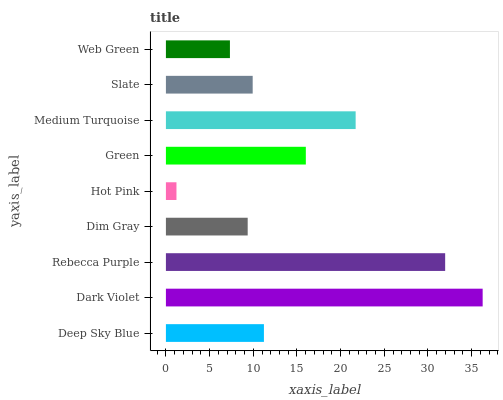Is Hot Pink the minimum?
Answer yes or no. Yes. Is Dark Violet the maximum?
Answer yes or no. Yes. Is Rebecca Purple the minimum?
Answer yes or no. No. Is Rebecca Purple the maximum?
Answer yes or no. No. Is Dark Violet greater than Rebecca Purple?
Answer yes or no. Yes. Is Rebecca Purple less than Dark Violet?
Answer yes or no. Yes. Is Rebecca Purple greater than Dark Violet?
Answer yes or no. No. Is Dark Violet less than Rebecca Purple?
Answer yes or no. No. Is Deep Sky Blue the high median?
Answer yes or no. Yes. Is Deep Sky Blue the low median?
Answer yes or no. Yes. Is Green the high median?
Answer yes or no. No. Is Dim Gray the low median?
Answer yes or no. No. 